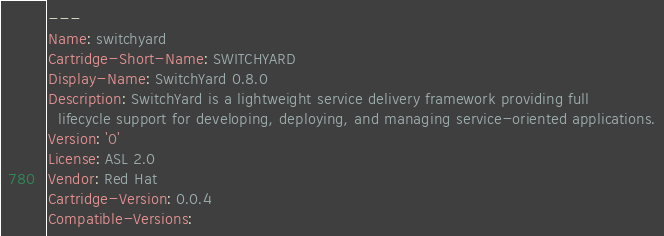<code> <loc_0><loc_0><loc_500><loc_500><_YAML_>---
Name: switchyard
Cartridge-Short-Name: SWITCHYARD
Display-Name: SwitchYard 0.8.0
Description: SwitchYard is a lightweight service delivery framework providing full
  lifecycle support for developing, deploying, and managing service-oriented applications.
Version: '0'
License: ASL 2.0
Vendor: Red Hat
Cartridge-Version: 0.0.4
Compatible-Versions:</code> 